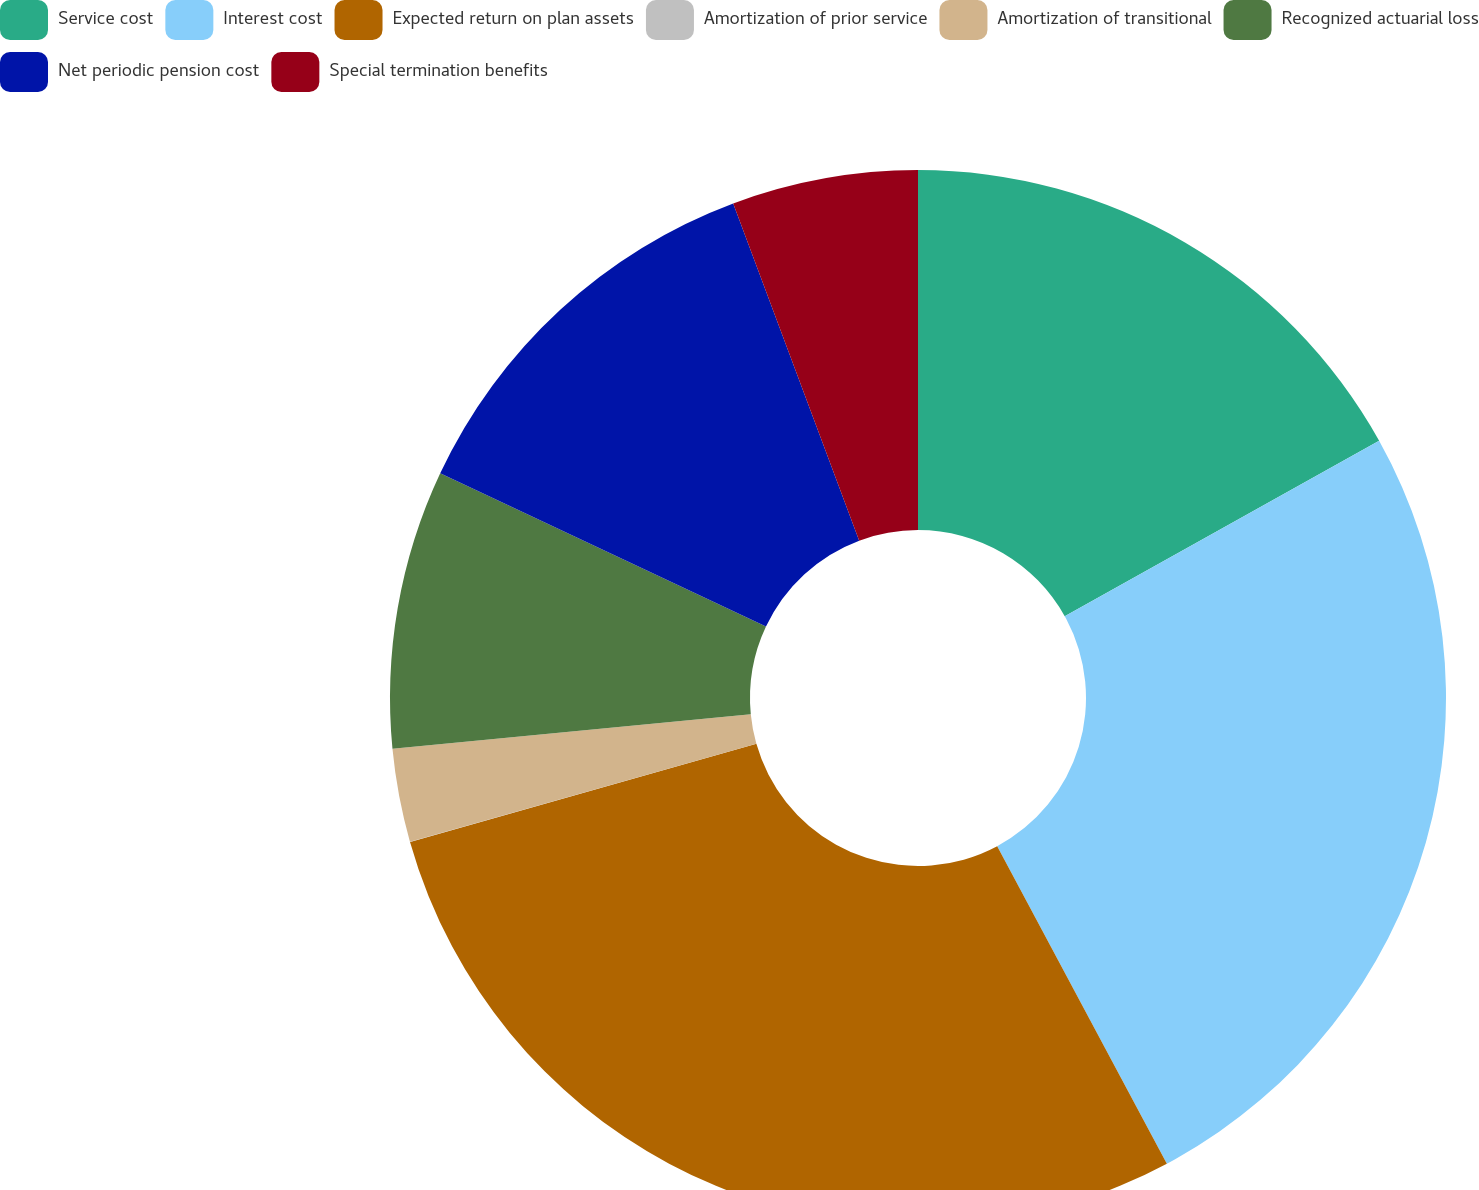Convert chart to OTSL. <chart><loc_0><loc_0><loc_500><loc_500><pie_chart><fcel>Service cost<fcel>Interest cost<fcel>Expected return on plan assets<fcel>Amortization of prior service<fcel>Amortization of transitional<fcel>Recognized actuarial loss<fcel>Net periodic pension cost<fcel>Special termination benefits<nl><fcel>16.9%<fcel>25.28%<fcel>28.41%<fcel>0.01%<fcel>2.85%<fcel>8.53%<fcel>12.31%<fcel>5.69%<nl></chart> 